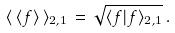Convert formula to latex. <formula><loc_0><loc_0><loc_500><loc_500>\langle \, \langle f \rangle \, \rangle _ { 2 , 1 } \, = \, \sqrt { \langle f | f \rangle _ { 2 , 1 } } \, .</formula> 